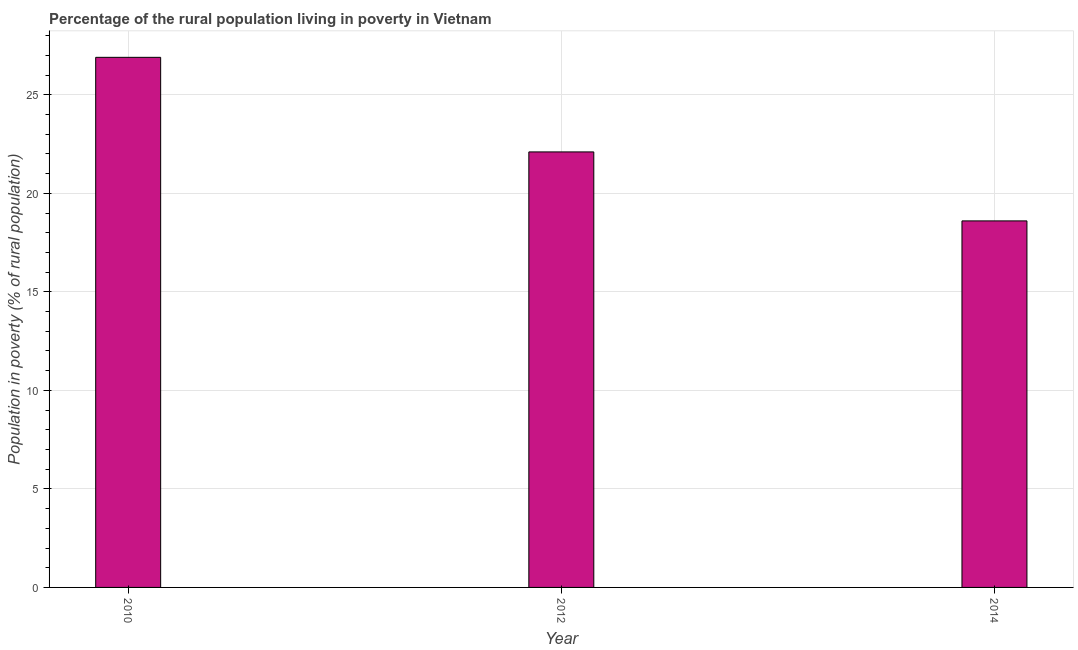Does the graph contain any zero values?
Keep it short and to the point. No. What is the title of the graph?
Your answer should be very brief. Percentage of the rural population living in poverty in Vietnam. What is the label or title of the X-axis?
Offer a very short reply. Year. What is the label or title of the Y-axis?
Offer a very short reply. Population in poverty (% of rural population). What is the percentage of rural population living below poverty line in 2010?
Your answer should be compact. 26.9. Across all years, what is the maximum percentage of rural population living below poverty line?
Ensure brevity in your answer.  26.9. In which year was the percentage of rural population living below poverty line maximum?
Provide a short and direct response. 2010. What is the sum of the percentage of rural population living below poverty line?
Your answer should be compact. 67.6. What is the average percentage of rural population living below poverty line per year?
Provide a short and direct response. 22.53. What is the median percentage of rural population living below poverty line?
Give a very brief answer. 22.1. What is the ratio of the percentage of rural population living below poverty line in 2012 to that in 2014?
Offer a very short reply. 1.19. What is the difference between the highest and the second highest percentage of rural population living below poverty line?
Offer a very short reply. 4.8. What is the difference between the highest and the lowest percentage of rural population living below poverty line?
Offer a terse response. 8.3. In how many years, is the percentage of rural population living below poverty line greater than the average percentage of rural population living below poverty line taken over all years?
Provide a short and direct response. 1. How many bars are there?
Keep it short and to the point. 3. Are all the bars in the graph horizontal?
Keep it short and to the point. No. What is the difference between two consecutive major ticks on the Y-axis?
Ensure brevity in your answer.  5. What is the Population in poverty (% of rural population) in 2010?
Your response must be concise. 26.9. What is the Population in poverty (% of rural population) in 2012?
Your answer should be compact. 22.1. What is the difference between the Population in poverty (% of rural population) in 2012 and 2014?
Provide a short and direct response. 3.5. What is the ratio of the Population in poverty (% of rural population) in 2010 to that in 2012?
Your response must be concise. 1.22. What is the ratio of the Population in poverty (% of rural population) in 2010 to that in 2014?
Your answer should be very brief. 1.45. What is the ratio of the Population in poverty (% of rural population) in 2012 to that in 2014?
Keep it short and to the point. 1.19. 